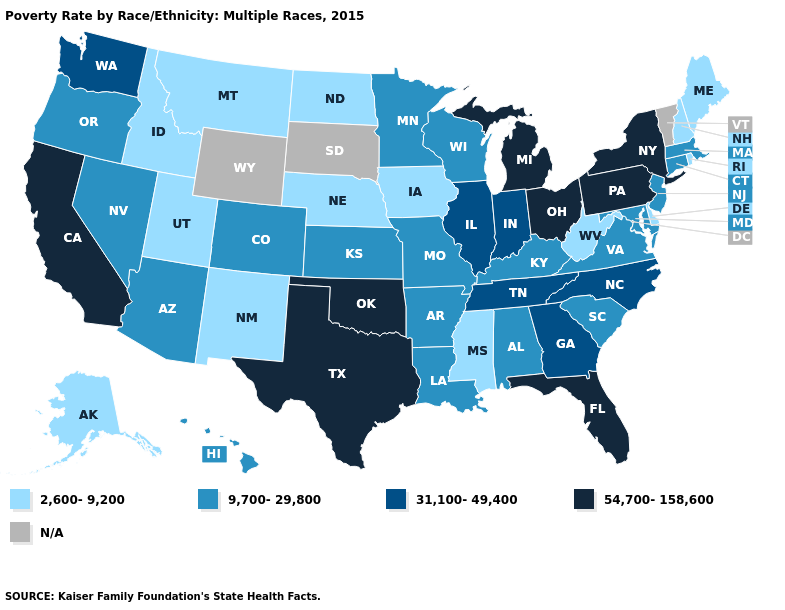What is the value of South Carolina?
Keep it brief. 9,700-29,800. What is the value of Montana?
Short answer required. 2,600-9,200. Which states hav the highest value in the MidWest?
Give a very brief answer. Michigan, Ohio. Among the states that border Maryland , which have the lowest value?
Answer briefly. Delaware, West Virginia. Name the states that have a value in the range N/A?
Concise answer only. South Dakota, Vermont, Wyoming. What is the lowest value in the USA?
Concise answer only. 2,600-9,200. Which states have the lowest value in the South?
Answer briefly. Delaware, Mississippi, West Virginia. Name the states that have a value in the range N/A?
Keep it brief. South Dakota, Vermont, Wyoming. What is the lowest value in states that border South Carolina?
Short answer required. 31,100-49,400. Name the states that have a value in the range 9,700-29,800?
Be succinct. Alabama, Arizona, Arkansas, Colorado, Connecticut, Hawaii, Kansas, Kentucky, Louisiana, Maryland, Massachusetts, Minnesota, Missouri, Nevada, New Jersey, Oregon, South Carolina, Virginia, Wisconsin. Does the first symbol in the legend represent the smallest category?
Give a very brief answer. Yes. What is the value of Oklahoma?
Write a very short answer. 54,700-158,600. What is the lowest value in the USA?
Answer briefly. 2,600-9,200. 